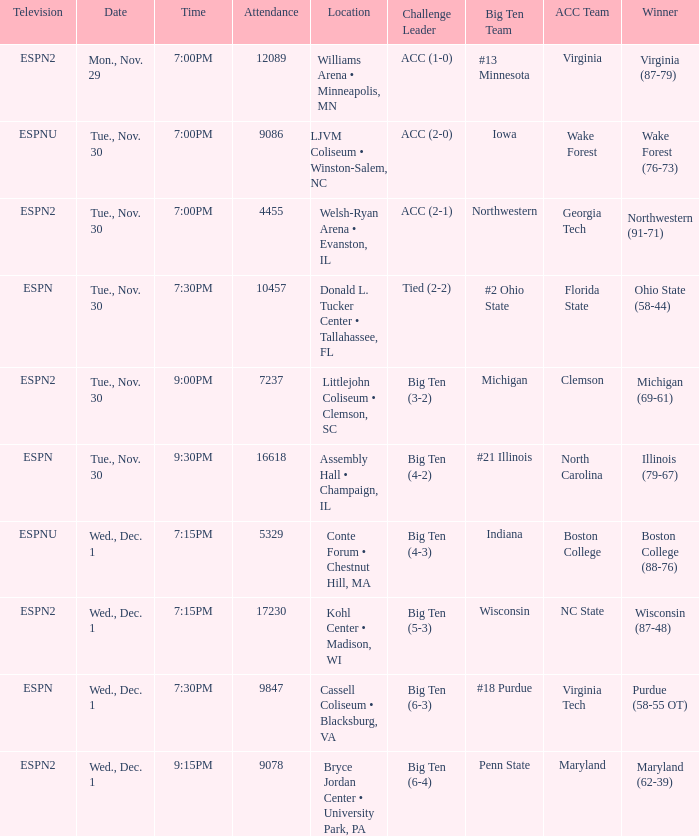What was the time of the games that took place at the cassell coliseum • blacksburg, va? 7:30PM. 